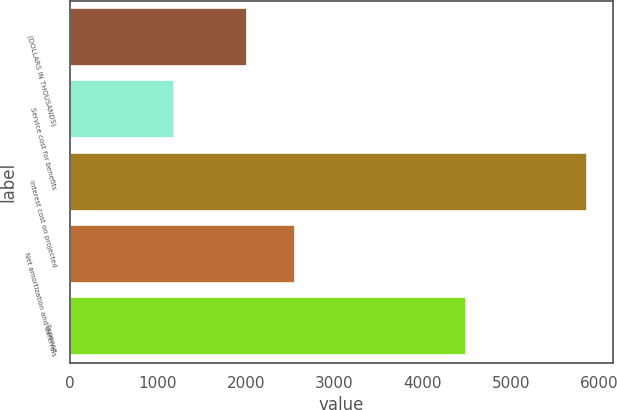<chart> <loc_0><loc_0><loc_500><loc_500><bar_chart><fcel>(DOLLARS IN THOUSANDS)<fcel>Service cost for benefits<fcel>Interest cost on projected<fcel>Net amortization and deferrals<fcel>Expense<nl><fcel>2011<fcel>1178<fcel>5861<fcel>2552<fcel>4487<nl></chart> 